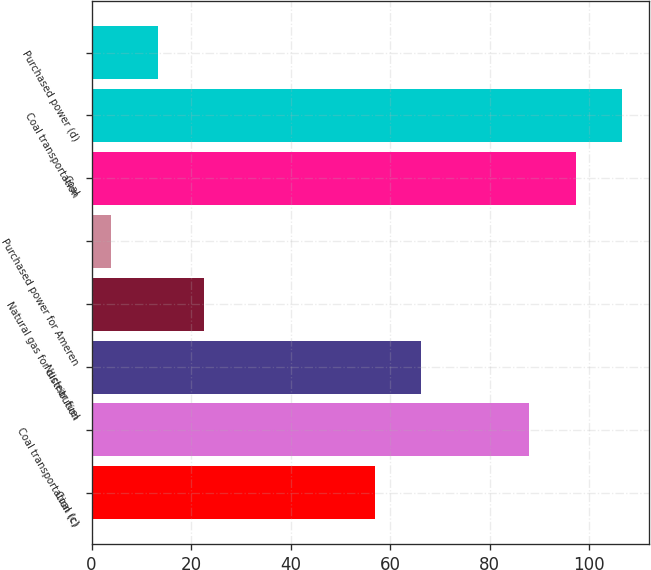Convert chart. <chart><loc_0><loc_0><loc_500><loc_500><bar_chart><fcel>Coal (c)<fcel>Coal transportation (c)<fcel>Nuclear fuel<fcel>Natural gas for distribution<fcel>Purchased power for Ameren<fcel>Coal<fcel>Coal transportation<fcel>Purchased power (d)<nl><fcel>57<fcel>88<fcel>66.3<fcel>22.6<fcel>4<fcel>97.3<fcel>106.6<fcel>13.3<nl></chart> 